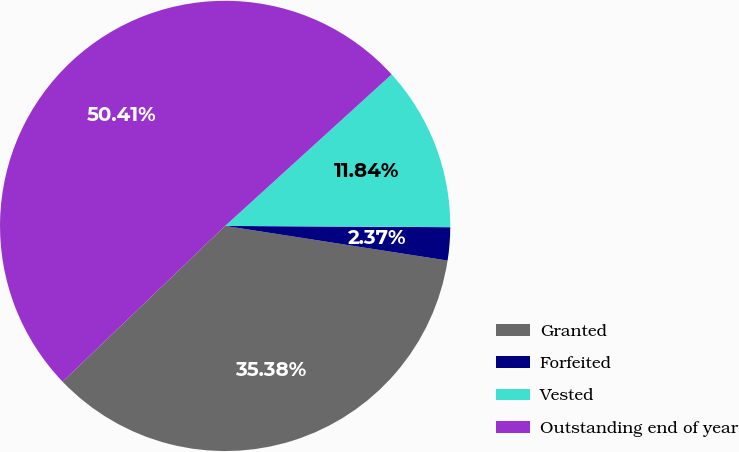<chart> <loc_0><loc_0><loc_500><loc_500><pie_chart><fcel>Granted<fcel>Forfeited<fcel>Vested<fcel>Outstanding end of year<nl><fcel>35.38%<fcel>2.37%<fcel>11.84%<fcel>50.42%<nl></chart> 